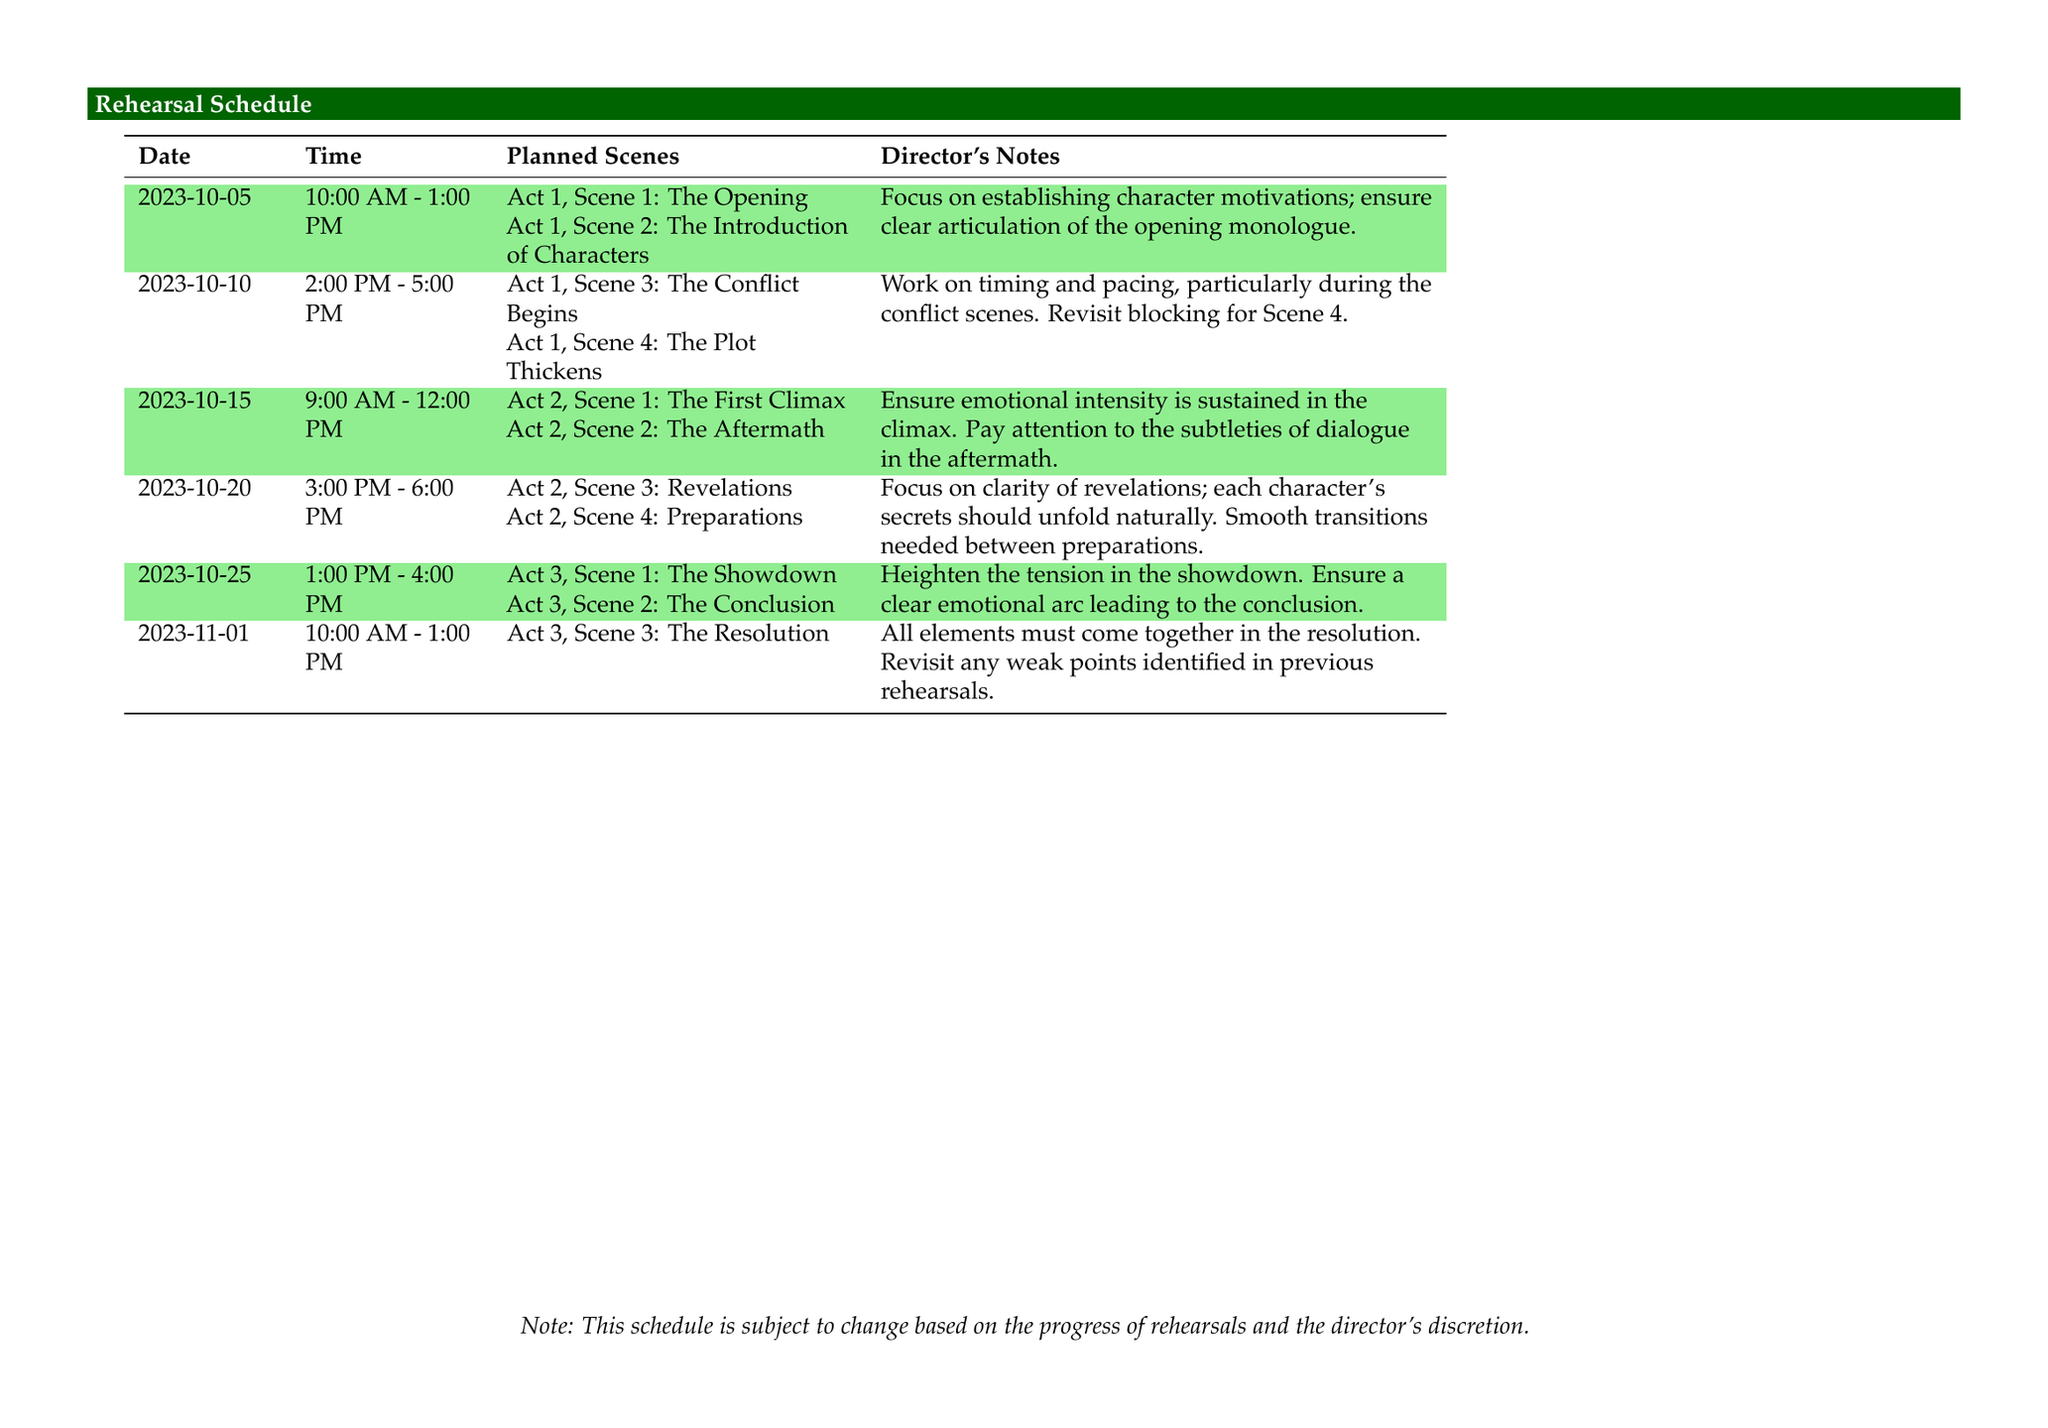What is the date of the first rehearsal? The first rehearsal is on October 5, 2023.
Answer: October 5, 2023 What scenes will be rehearsed on October 10, 2023? On October 10, 2023, Act 1, Scene 3 and Act 1, Scene 4 will be rehearsed.
Answer: Act 1, Scene 3: The Conflict Begins; Act 1, Scene 4: The Plot Thickens How many hours is the rehearsal on October 25, 2023? The rehearsal on October 25, 2023, lasts for 3 hours.
Answer: 3 hours What focus is mentioned for the rehearsal on October 15, 2023? The focus mentioned is on ensuring emotional intensity in the climax and paying attention to dialogue subtleties.
Answer: Emotional intensity; subtleties of dialogue What director's notes are provided for the rehearsal on November 1, 2023? The notes emphasize that all elements must come together and to revisit any weak points identified.
Answer: All elements must come together; revisit weak points 